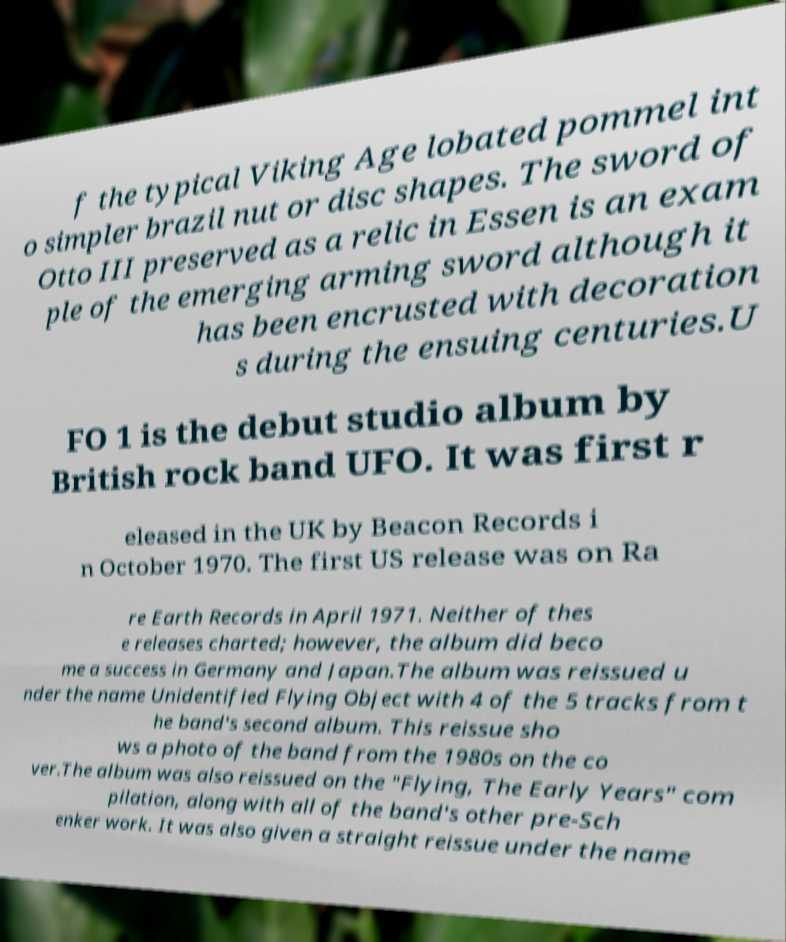Can you read and provide the text displayed in the image?This photo seems to have some interesting text. Can you extract and type it out for me? f the typical Viking Age lobated pommel int o simpler brazil nut or disc shapes. The sword of Otto III preserved as a relic in Essen is an exam ple of the emerging arming sword although it has been encrusted with decoration s during the ensuing centuries.U FO 1 is the debut studio album by British rock band UFO. It was first r eleased in the UK by Beacon Records i n October 1970. The first US release was on Ra re Earth Records in April 1971. Neither of thes e releases charted; however, the album did beco me a success in Germany and Japan.The album was reissued u nder the name Unidentified Flying Object with 4 of the 5 tracks from t he band's second album. This reissue sho ws a photo of the band from the 1980s on the co ver.The album was also reissued on the "Flying, The Early Years" com pilation, along with all of the band's other pre-Sch enker work. It was also given a straight reissue under the name 